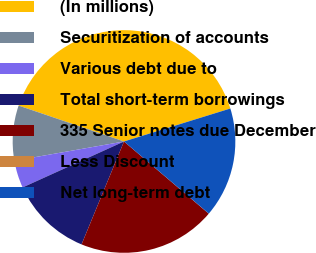Convert chart. <chart><loc_0><loc_0><loc_500><loc_500><pie_chart><fcel>(In millions)<fcel>Securitization of accounts<fcel>Various debt due to<fcel>Total short-term borrowings<fcel>335 Senior notes due December<fcel>Less Discount<fcel>Net long-term debt<nl><fcel>39.99%<fcel>8.0%<fcel>4.0%<fcel>12.0%<fcel>20.0%<fcel>0.01%<fcel>16.0%<nl></chart> 